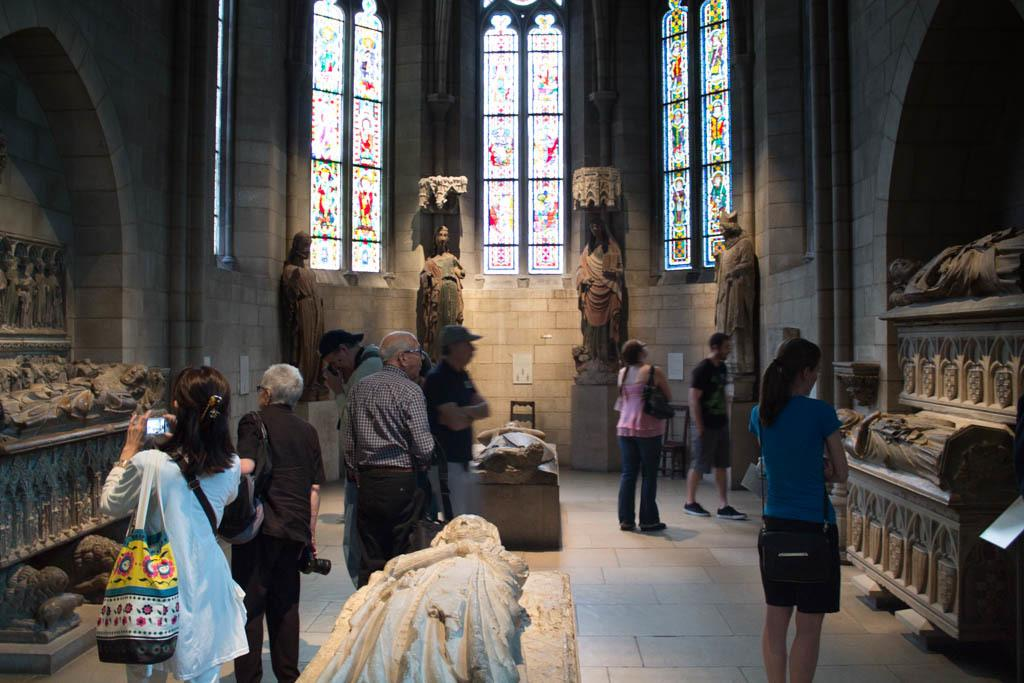What is the main subject of the image? The main subject of the image is a group of people standing. What else can be seen in the image besides the people? There are cars and sculptures visible in the image. What is visible in the background of the image? There are windows visible in the background of the image. What type of air is being used to create the sculptures in the image? There is no indication in the image that the sculptures are being created using air. 